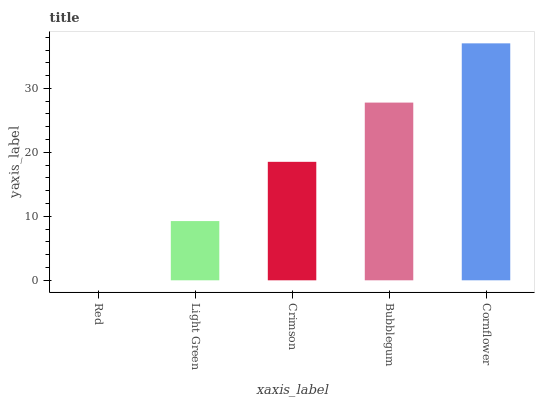Is Red the minimum?
Answer yes or no. Yes. Is Cornflower the maximum?
Answer yes or no. Yes. Is Light Green the minimum?
Answer yes or no. No. Is Light Green the maximum?
Answer yes or no. No. Is Light Green greater than Red?
Answer yes or no. Yes. Is Red less than Light Green?
Answer yes or no. Yes. Is Red greater than Light Green?
Answer yes or no. No. Is Light Green less than Red?
Answer yes or no. No. Is Crimson the high median?
Answer yes or no. Yes. Is Crimson the low median?
Answer yes or no. Yes. Is Light Green the high median?
Answer yes or no. No. Is Red the low median?
Answer yes or no. No. 